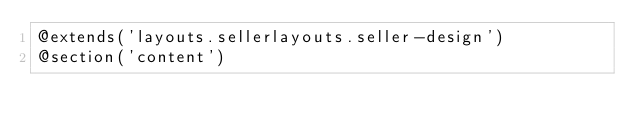Convert code to text. <code><loc_0><loc_0><loc_500><loc_500><_PHP_>@extends('layouts.sellerlayouts.seller-design')
@section('content')</code> 